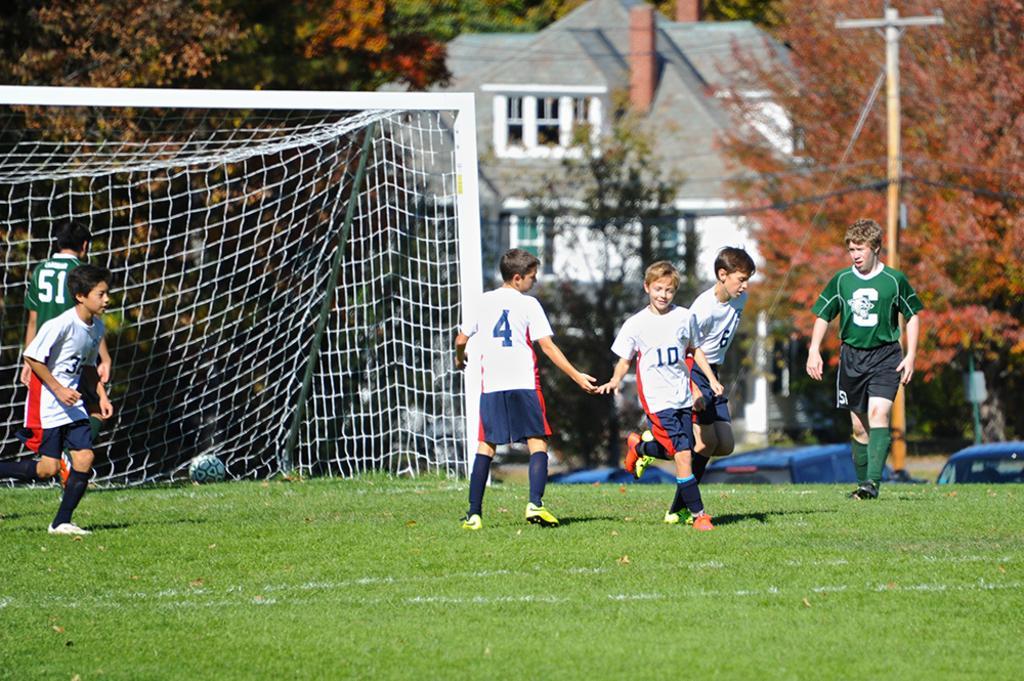Can you describe this image briefly? In this image we can see children standing on the ground, sports netball, buildings, street pole, cables and trees. 